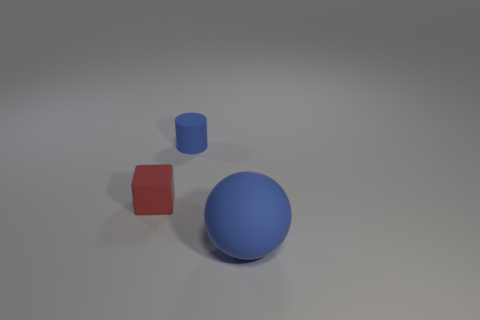Add 2 large blue balls. How many objects exist? 5 Subtract all cubes. How many objects are left? 2 Subtract all red matte cubes. Subtract all large objects. How many objects are left? 1 Add 3 large balls. How many large balls are left? 4 Add 2 blue rubber cylinders. How many blue rubber cylinders exist? 3 Subtract 0 cyan blocks. How many objects are left? 3 